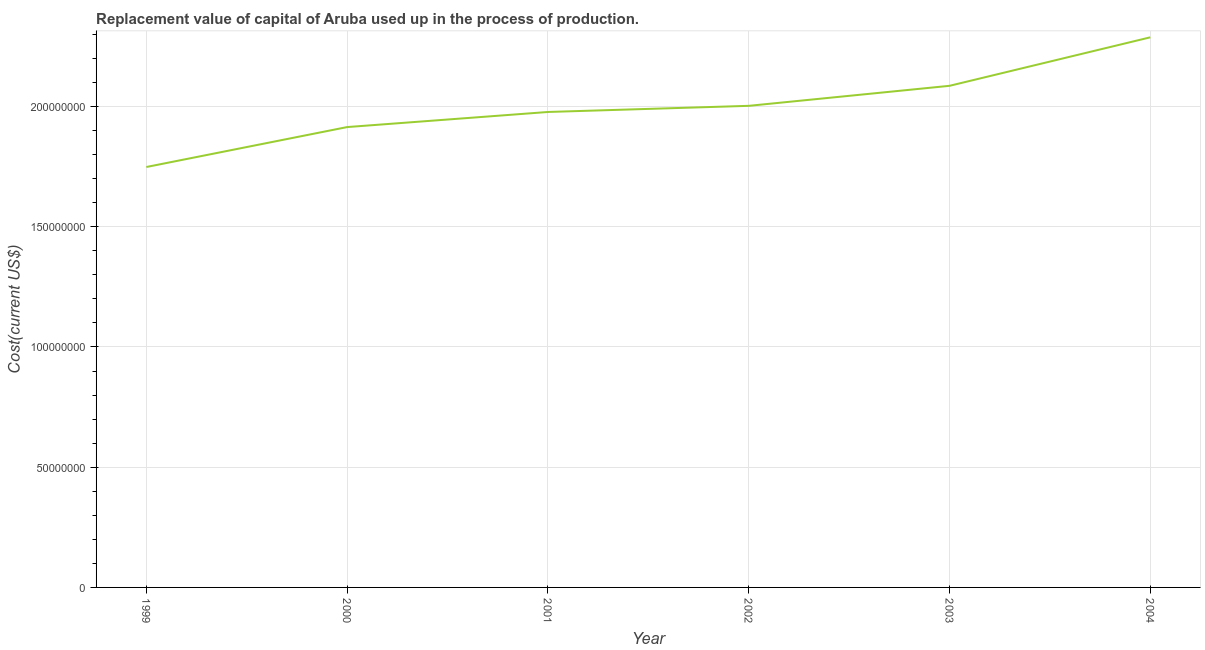What is the consumption of fixed capital in 2003?
Keep it short and to the point. 2.09e+08. Across all years, what is the maximum consumption of fixed capital?
Your response must be concise. 2.29e+08. Across all years, what is the minimum consumption of fixed capital?
Provide a succinct answer. 1.75e+08. In which year was the consumption of fixed capital maximum?
Your answer should be compact. 2004. In which year was the consumption of fixed capital minimum?
Your response must be concise. 1999. What is the sum of the consumption of fixed capital?
Provide a succinct answer. 1.20e+09. What is the difference between the consumption of fixed capital in 1999 and 2001?
Make the answer very short. -2.29e+07. What is the average consumption of fixed capital per year?
Your response must be concise. 2.00e+08. What is the median consumption of fixed capital?
Offer a very short reply. 1.99e+08. Do a majority of the years between 2001 and 2002 (inclusive) have consumption of fixed capital greater than 210000000 US$?
Keep it short and to the point. No. What is the ratio of the consumption of fixed capital in 2002 to that in 2003?
Your response must be concise. 0.96. Is the consumption of fixed capital in 2002 less than that in 2003?
Ensure brevity in your answer.  Yes. What is the difference between the highest and the second highest consumption of fixed capital?
Your answer should be compact. 2.02e+07. Is the sum of the consumption of fixed capital in 1999 and 2000 greater than the maximum consumption of fixed capital across all years?
Keep it short and to the point. Yes. What is the difference between the highest and the lowest consumption of fixed capital?
Your answer should be very brief. 5.39e+07. In how many years, is the consumption of fixed capital greater than the average consumption of fixed capital taken over all years?
Provide a succinct answer. 2. How many lines are there?
Your answer should be compact. 1. What is the difference between two consecutive major ticks on the Y-axis?
Your response must be concise. 5.00e+07. Are the values on the major ticks of Y-axis written in scientific E-notation?
Offer a terse response. No. Does the graph contain any zero values?
Keep it short and to the point. No. What is the title of the graph?
Your response must be concise. Replacement value of capital of Aruba used up in the process of production. What is the label or title of the X-axis?
Your answer should be compact. Year. What is the label or title of the Y-axis?
Provide a short and direct response. Cost(current US$). What is the Cost(current US$) of 1999?
Your answer should be compact. 1.75e+08. What is the Cost(current US$) in 2000?
Provide a succinct answer. 1.91e+08. What is the Cost(current US$) in 2001?
Offer a very short reply. 1.98e+08. What is the Cost(current US$) of 2002?
Provide a succinct answer. 2.00e+08. What is the Cost(current US$) in 2003?
Make the answer very short. 2.09e+08. What is the Cost(current US$) of 2004?
Your answer should be compact. 2.29e+08. What is the difference between the Cost(current US$) in 1999 and 2000?
Your response must be concise. -1.66e+07. What is the difference between the Cost(current US$) in 1999 and 2001?
Keep it short and to the point. -2.29e+07. What is the difference between the Cost(current US$) in 1999 and 2002?
Your answer should be compact. -2.54e+07. What is the difference between the Cost(current US$) in 1999 and 2003?
Provide a short and direct response. -3.38e+07. What is the difference between the Cost(current US$) in 1999 and 2004?
Provide a short and direct response. -5.39e+07. What is the difference between the Cost(current US$) in 2000 and 2001?
Keep it short and to the point. -6.28e+06. What is the difference between the Cost(current US$) in 2000 and 2002?
Provide a succinct answer. -8.83e+06. What is the difference between the Cost(current US$) in 2000 and 2003?
Your answer should be very brief. -1.72e+07. What is the difference between the Cost(current US$) in 2000 and 2004?
Ensure brevity in your answer.  -3.73e+07. What is the difference between the Cost(current US$) in 2001 and 2002?
Offer a terse response. -2.55e+06. What is the difference between the Cost(current US$) in 2001 and 2003?
Your answer should be very brief. -1.09e+07. What is the difference between the Cost(current US$) in 2001 and 2004?
Provide a succinct answer. -3.11e+07. What is the difference between the Cost(current US$) in 2002 and 2003?
Offer a very short reply. -8.33e+06. What is the difference between the Cost(current US$) in 2002 and 2004?
Your response must be concise. -2.85e+07. What is the difference between the Cost(current US$) in 2003 and 2004?
Keep it short and to the point. -2.02e+07. What is the ratio of the Cost(current US$) in 1999 to that in 2000?
Your answer should be very brief. 0.91. What is the ratio of the Cost(current US$) in 1999 to that in 2001?
Ensure brevity in your answer.  0.88. What is the ratio of the Cost(current US$) in 1999 to that in 2002?
Give a very brief answer. 0.87. What is the ratio of the Cost(current US$) in 1999 to that in 2003?
Provide a succinct answer. 0.84. What is the ratio of the Cost(current US$) in 1999 to that in 2004?
Provide a succinct answer. 0.76. What is the ratio of the Cost(current US$) in 2000 to that in 2001?
Offer a very short reply. 0.97. What is the ratio of the Cost(current US$) in 2000 to that in 2002?
Keep it short and to the point. 0.96. What is the ratio of the Cost(current US$) in 2000 to that in 2003?
Your answer should be compact. 0.92. What is the ratio of the Cost(current US$) in 2000 to that in 2004?
Ensure brevity in your answer.  0.84. What is the ratio of the Cost(current US$) in 2001 to that in 2003?
Your response must be concise. 0.95. What is the ratio of the Cost(current US$) in 2001 to that in 2004?
Offer a terse response. 0.86. What is the ratio of the Cost(current US$) in 2003 to that in 2004?
Your answer should be very brief. 0.91. 